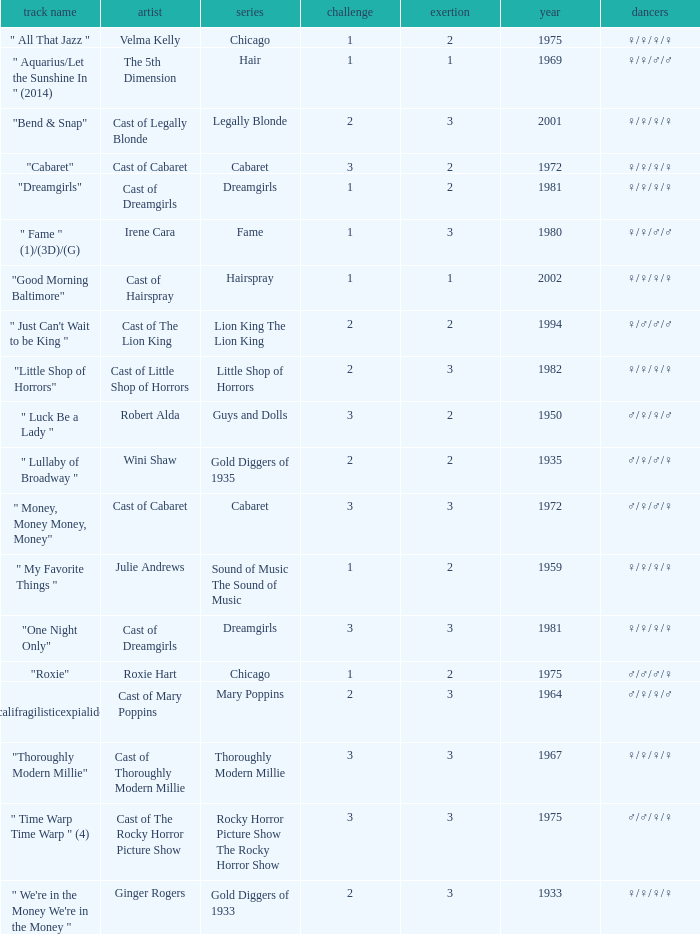Would you mind parsing the complete table? {'header': ['track name', 'artist', 'series', 'challenge', 'exertion', 'year', 'dancers'], 'rows': [['" All That Jazz "', 'Velma Kelly', 'Chicago', '1', '2', '1975', '♀/♀/♀/♀'], ['" Aquarius/Let the Sunshine In " (2014)', 'The 5th Dimension', 'Hair', '1', '1', '1969', '♀/♀/♂/♂'], ['"Bend & Snap"', 'Cast of Legally Blonde', 'Legally Blonde', '2', '3', '2001', '♀/♀/♀/♀'], ['"Cabaret"', 'Cast of Cabaret', 'Cabaret', '3', '2', '1972', '♀/♀/♀/♀'], ['"Dreamgirls"', 'Cast of Dreamgirls', 'Dreamgirls', '1', '2', '1981', '♀/♀/♀/♀'], ['" Fame " (1)/(3D)/(G)', 'Irene Cara', 'Fame', '1', '3', '1980', '♀/♀/♂/♂'], ['"Good Morning Baltimore"', 'Cast of Hairspray', 'Hairspray', '1', '1', '2002', '♀/♀/♀/♀'], ['" Just Can\'t Wait to be King "', 'Cast of The Lion King', 'Lion King The Lion King', '2', '2', '1994', '♀/♂/♂/♂'], ['"Little Shop of Horrors"', 'Cast of Little Shop of Horrors', 'Little Shop of Horrors', '2', '3', '1982', '♀/♀/♀/♀'], ['" Luck Be a Lady "', 'Robert Alda', 'Guys and Dolls', '3', '2', '1950', '♂/♀/♀/♂'], ['" Lullaby of Broadway "', 'Wini Shaw', 'Gold Diggers of 1935', '2', '2', '1935', '♂/♀/♂/♀'], ['" Money, Money Money, Money"', 'Cast of Cabaret', 'Cabaret', '3', '3', '1972', '♂/♀/♂/♀'], ['" My Favorite Things "', 'Julie Andrews', 'Sound of Music The Sound of Music', '1', '2', '1959', '♀/♀/♀/♀'], ['"One Night Only"', 'Cast of Dreamgirls', 'Dreamgirls', '3', '3', '1981', '♀/♀/♀/♀'], ['"Roxie"', 'Roxie Hart', 'Chicago', '1', '2', '1975', '♂/♂/♂/♀'], ['" Supercalifragilisticexpialidocious " (DP)', 'Cast of Mary Poppins', 'Mary Poppins', '2', '3', '1964', '♂/♀/♀/♂'], ['"Thoroughly Modern Millie"', 'Cast of Thoroughly Modern Millie', 'Thoroughly Modern Millie', '3', '3', '1967', '♀/♀/♀/♀'], ['" Time Warp Time Warp " (4)', 'Cast of The Rocky Horror Picture Show', 'Rocky Horror Picture Show The Rocky Horror Show', '3', '3', '1975', '♂/♂/♀/♀'], ['" We\'re in the Money We\'re in the Money "', 'Ginger Rogers', 'Gold Diggers of 1933', '2', '3', '1933', '♀/♀/♀/♀']]} How many artists were there for the show thoroughly modern millie? 1.0. 